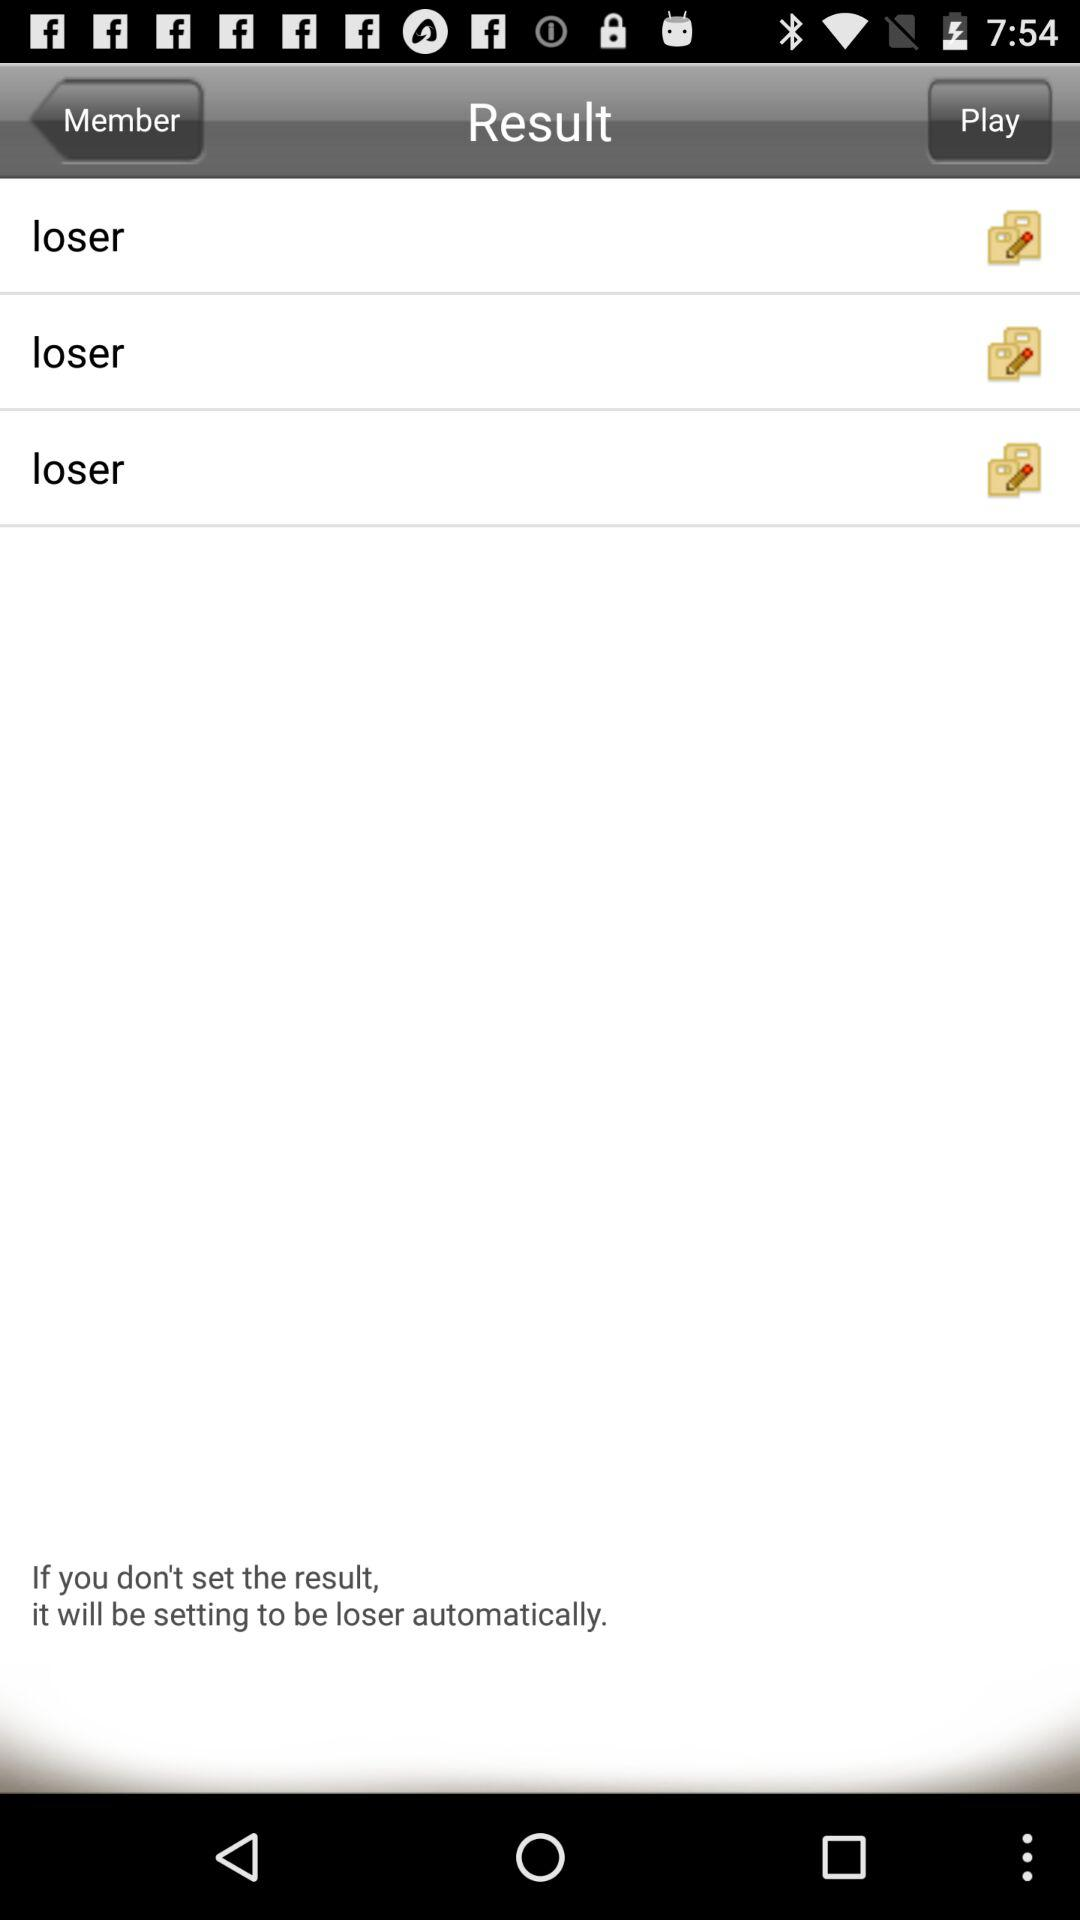How many items have the text 'loser'?
Answer the question using a single word or phrase. 3 